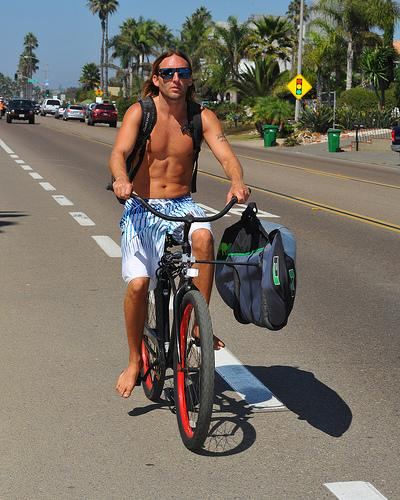Describe the person's facial features and their accessories. The person has a head with a nose, mouth, chin, and ears. They are wearing sunglasses. How many people are present in the image? There is one person in the image. Briefly mention the attire of the person riding the bike. The person is shirtless and shoeless, wearing shorts and a backpack. Analyze the interaction between the person and the bike. The man is riding the bike, holding onto the handlebars and pedaling with his feet on the pedals. What street markings can be observed in the image? Lane markers for traffic and lettering on the street are visible. What type of vehicle is the person interacting with in this image? The person is interacting with a bike. Assess the quality of the image with respect to the objects presented. The image quality seems good, with detailed information about the person, bike, and various features. Inspect the scene and describe any other objects or subjects of interest on the street. Vehicles are present on the street as well as lane markers and lettering on the street surface. What is the person doing in the image? Riding a bike without a shirt or shoes. Identify and describe the vehicles in the background of the image. Vehicles on the street (X:2 Y:82 Width:115 Height:115) Create a semantic segmentation of the person and parts of his body in the image. Head, hair, ears, sunglasses, nose, mouth, chin, abs, arms, hands, legs, and feet. Answer the question based on the image - Which hand of the person is better visible in the image, left or right? Left hand How many traffic lanes are visible in the image? Two traffic lanes Describe the attributes of the objects in the image, focusing on the person on the bike. Shirtless guy, no shoes, shorts, backpack straps, and sunglasses. List the elements of the person's bike featured in this picture. Front tire, rear tire, and bag. In this image, there's an ice cream truck parked on the side of the road. Please locate it. None of the objects mention an ice cream truck, a truck, or an ice cream, which makes this instruction misleading as no such element is present in the image. Analyze if the image has any abnormalities related to the person or the bike. The man is shirtless and not wearing shoes while riding the bike. Assess whether the person in the image seems to be following traffic rules. Cannot determine with given information. Determine the emotional tone of the image. Casual and carefree Detect any text visible in the image. Lettering on the street (X:165 Y:194 Width:110 Height:110) What is the color of the front tire of the bike? Color information not provided. Notice the green traffic light at the intersection. What do you think it means? There is no mention of a traffic light, intersection, or any color-related information in the objects provided, creating confusion for the viewer attempting to locate this non-existent object. Believe it or not, there is a hidden treasure chest underneath the parked car. Can you spot it? There is no mention of a treasure chest or a parked car in the objects, making it impossible for the viewer to locate these items in the image, as they do not exist. Locate the position of the shorts on the person in the image. X:115 Y:196 Width:105 Height:105 Does the person in the image have any special features on their face or head? Sunglasses and bare chest Identify any unusual elements in the image. A shirtless man riding a bike without shoes. Can you find the little dog wearing a pink collar in the image? There is no mention of a dog or a pink collar in any of the objects provided in the metadata. Thus, it would mislead the viewer into looking for a non-existent object. Can you identify the brand name of the skateboard propped against the wall behind the guy? There is no mention of a skateboard or a wall in the objects, so the viewer will be searching for non-existent items, leading to confusion and frustration. The woman wearing a red dress is passing by the shirtless man. What do you think they might be talking about? Although there is a mention of a shirtless man, there are no objects describing a woman or a red dress in the image. This misleading instruction will confuse the viewer into searching for a woman who isn't present. Describe the scene depicted in this image. A shirtless man is riding a bike on a street with traffic lanes and vehicles in the background. Analyze the interactions between different objects in the image. The man is riding the bike, and the tires are in contact with the street. Determine the quality of the image with respect to details and clarity. High quality image with clear and detailed objects. List all the facial features of the shirtless guy visible in the image. Head, hair, ears, sunglasses, nose, mouth, and chin. 